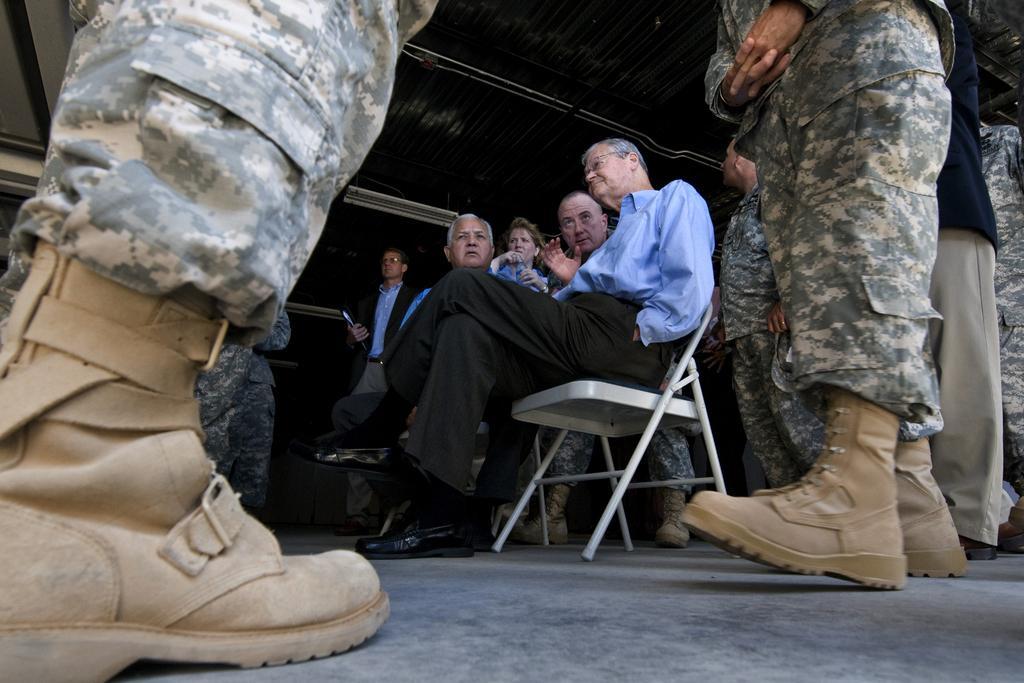In one or two sentences, can you explain what this image depicts? There are a two people who are sitting on a chair and having a conversation. Here we can see a soldier on the right side and we can observe a soldier shoe on the left side. 